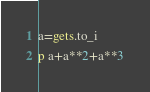<code> <loc_0><loc_0><loc_500><loc_500><_Ruby_>a=gets.to_i
p a+a**2+a**3</code> 